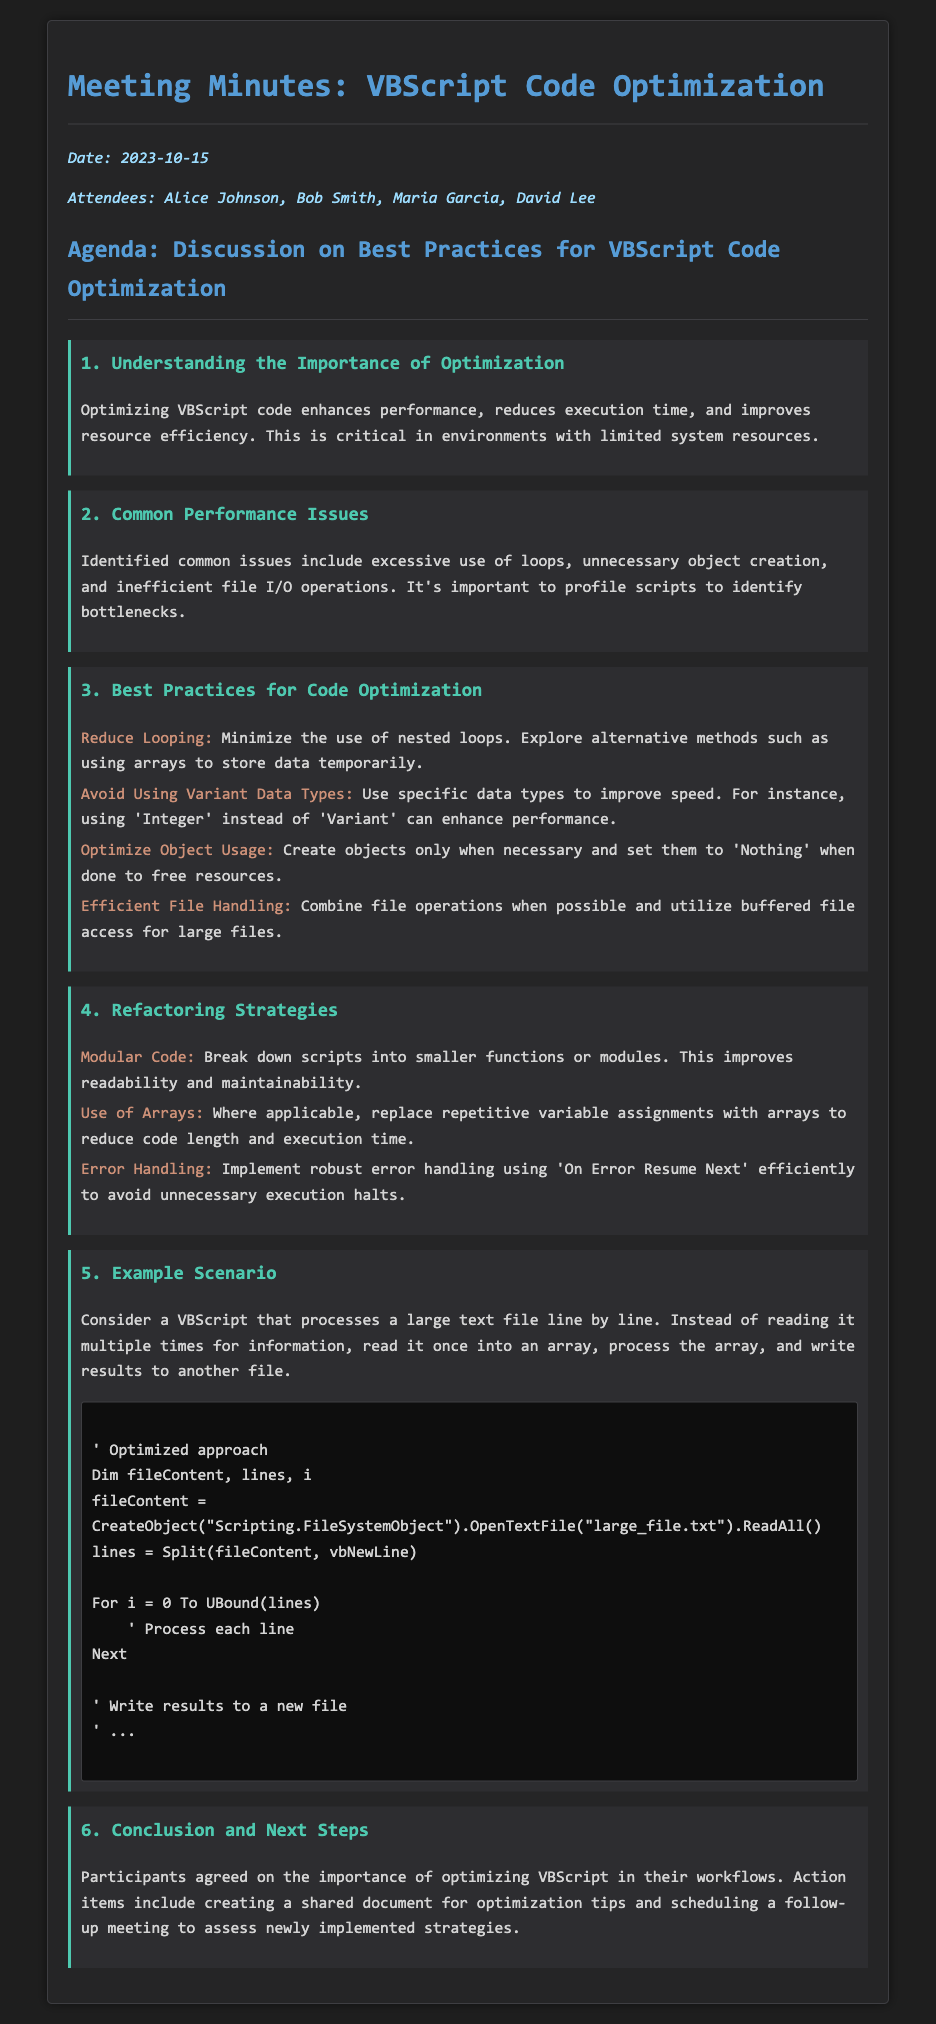What is the date of the meeting? The date of the meeting is mentioned at the top of the document.
Answer: 2023-10-15 Who is one of the attendees? Attendees are listed in the document, and at least one name can be found.
Answer: Alice Johnson What is one common performance issue mentioned? The document lists several common performance issues related to VBScript.
Answer: Excessive use of loops What is one suggested refactoring strategy? The document outlines various refactoring strategies to enhance code quality.
Answer: Modular Code How does reading a file efficiently improve performance? The example scenario illustrates a method to read a file more efficiently in VBScript.
Answer: Read it once into an array What is the purpose of setting objects to 'Nothing'? The document explains object management practices important for resource management.
Answer: Free resources How many key points are listed under best practices? The number of best practices is explicitly mentioned in the document's structure.
Answer: Four What action item was agreed upon during the meeting? Action items are noted in the conclusion section of the document outlining further steps.
Answer: Creating a shared document What color is used for the code block? The document contains specific styling cues about the appearance of certain elements.
Answer: #0E0E0E 